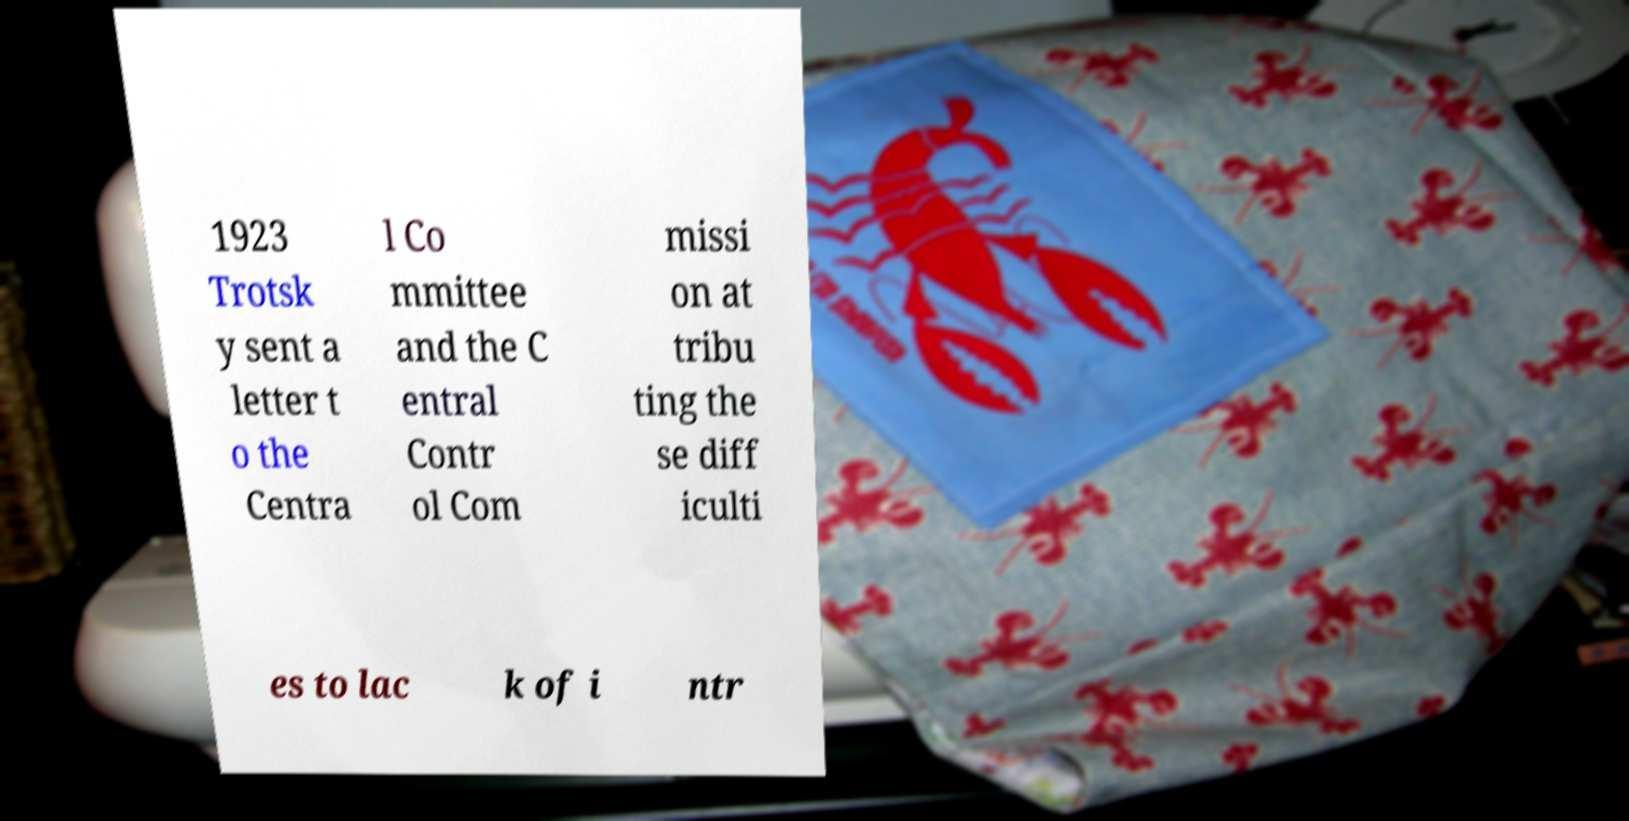Could you assist in decoding the text presented in this image and type it out clearly? 1923 Trotsk y sent a letter t o the Centra l Co mmittee and the C entral Contr ol Com missi on at tribu ting the se diff iculti es to lac k of i ntr 